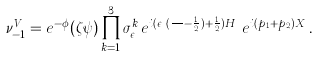Convert formula to latex. <formula><loc_0><loc_0><loc_500><loc_500>\nu ^ { V } _ { - 1 } = e ^ { - \phi } ( \zeta \psi ) \prod ^ { 3 } _ { k = 1 } \sigma _ { \epsilon _ { k } } ^ { k } e ^ { i ( \epsilon _ { k } ( \frac { \phi _ { k } } { \pi } - \frac { 1 } { 2 } ) + \frac { 1 } { 2 } ) H _ { k } } e ^ { i ( p _ { 1 } + p _ { 2 } ) X } \, .</formula> 